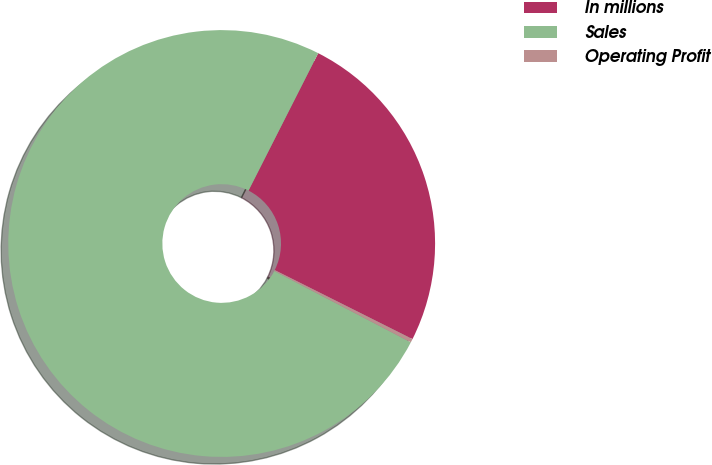<chart> <loc_0><loc_0><loc_500><loc_500><pie_chart><fcel>In millions<fcel>Sales<fcel>Operating Profit<nl><fcel>24.92%<fcel>74.81%<fcel>0.27%<nl></chart> 